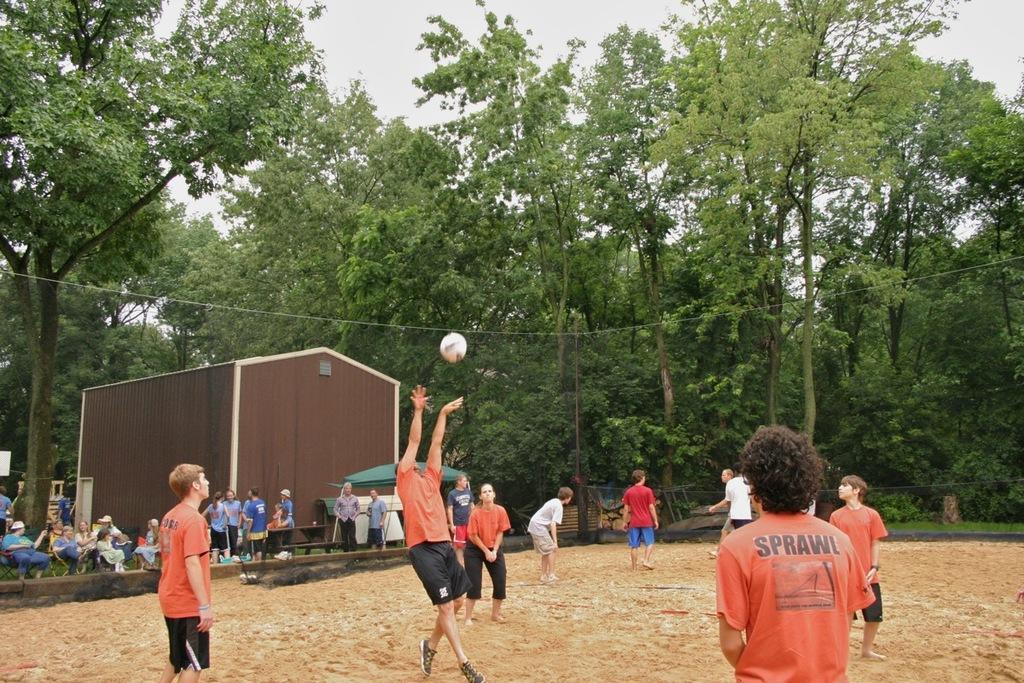Describe this image in one or two sentences. In the image we can see there are people standing on the ground and there is a ball in the air. There is a building and there are other people sitting on the chair. Behind there are trees and there is a clear sky. 